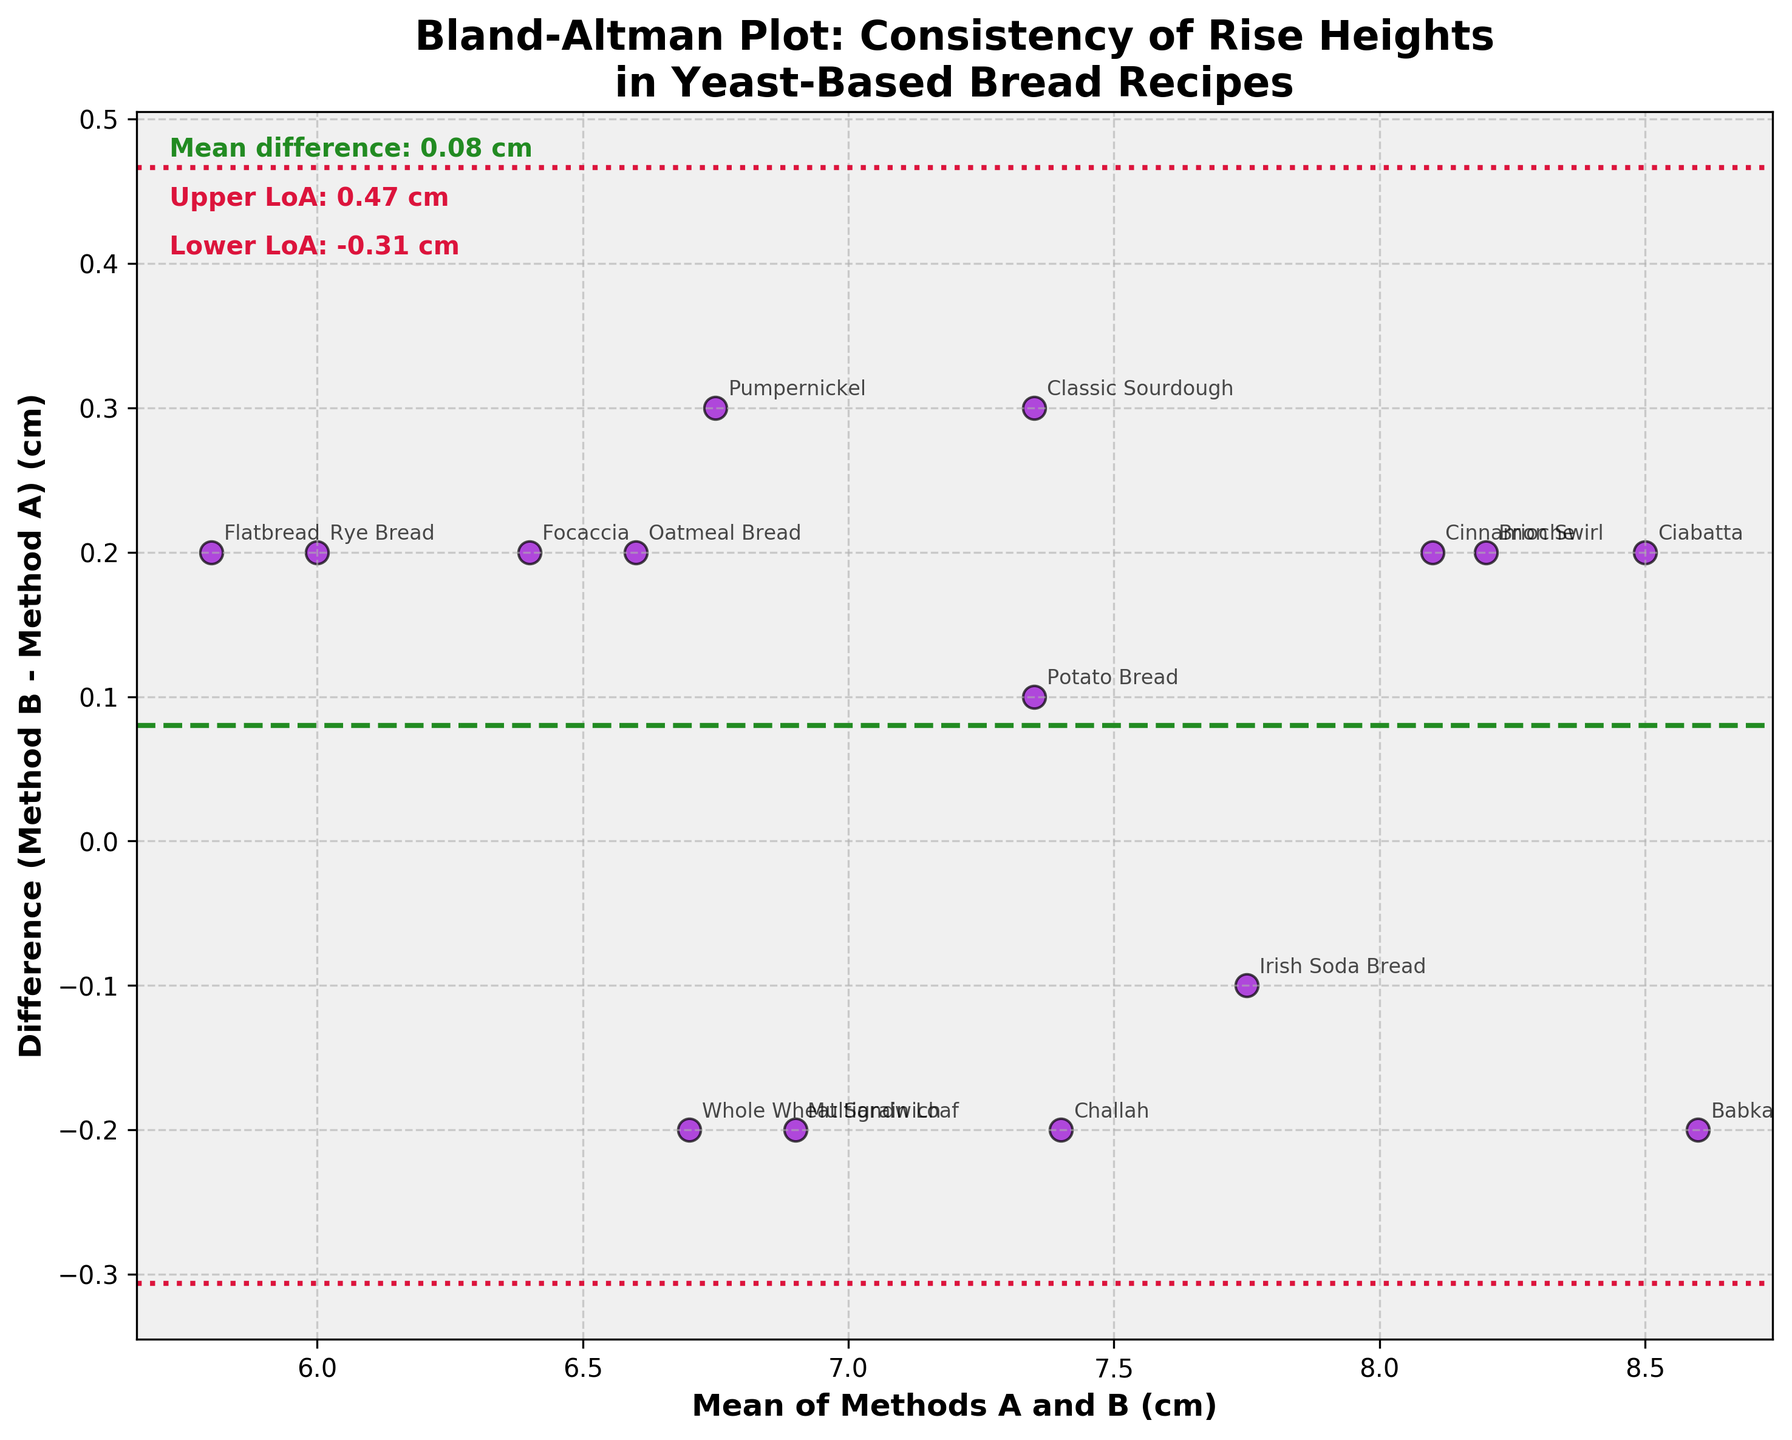What is the title of the plot? The title is clearly visible at the top of the plot.
Answer: Bland-Altman Plot: Consistency of Rise Heights in Yeast-Based Bread Recipes How many data points are shown in the plot? To find the number of data points, count the number of scatter points on the plot. There should be as many points as there are bread recipes listed.
Answer: 15 What are the colors of the scatter points and lines in the plot? Identify the colors by visual inspection. Scatter points are dark purple, the mean difference line is green, and the limits of agreement lines are red.
Answer: Dark purple for scatter points, green for mean difference, red for limits of agreement What is the mean difference between Method B and Method A? The mean difference is provided in the text on the plot and is shown by a green dashed line across the plot.
Answer: 0.12 cm What are the upper and lower limits of agreement? The upper and lower limits are shown by the red dotted lines, and their exact values are provided in the text on the plot.
Answer: Upper: 0.43 cm, Lower: -0.19 cm Which bread recipe has the largest difference between Method B and Method A? Identify the data point that lies farthest from the mean difference line and find the associated bread recipe label.
Answer: Babka Which recipe has a rise height difference closest to the mean difference? Look for the data point that is closest to the green dashed line and identify the associated recipe.
Answer: Potato Bread How many recipes have a rise height difference greater than the mean difference? Count the number of data points above the green dashed line indicating a positive difference greater than 0.12 cm.
Answer: 9 Is the mean difference between Method B and Method A positive or negative? Check the direction of the green dashed line relative to the zero line to determine if it is positive or negative.
Answer: Positive For which bread recipe do the two methods produce almost identical rise heights? Find the data point that is closest to the zero line, where the difference between the methods is very small.
Answer: Irish Soda Bread Is the spread of differences between Method B and Method A larger for recipes with higher or lower rise heights? Analyze the plot to see if the scatter points are more spread out for higher or lower means.
Answer: Higher rise heights Comparing the mean difference and limits of agreement, is the variation between the methods large? Compare the mean difference with the limits of agreement to judge if the variation is relatively small or large. The limits of agreement give an interval within which 95% of the differences are expected to lie.
Answer: No, it is relatively small 